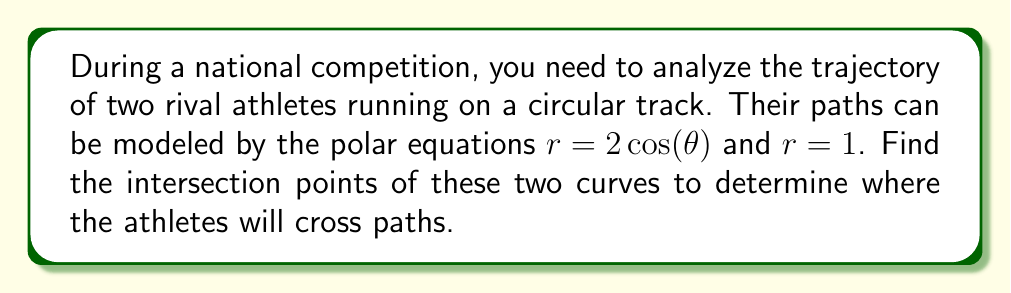Can you answer this question? To find the intersection points of the two polar curves, we need to solve the equation:

$2\cos(\theta) = 1$

Step 1: Isolate $\cos(\theta)$
$$\cos(\theta) = \frac{1}{2}$$

Step 2: Recall that $\cos(\theta) = \frac{1}{2}$ occurs at $\theta = \pm \frac{\pi}{3}$ in the interval $[0, 2\pi]$

Step 3: Convert the polar coordinates to Cartesian coordinates
For $\theta = \frac{\pi}{3}$:
$x = r\cos(\theta) = 1 \cdot \cos(\frac{\pi}{3}) = \frac{1}{2}$
$y = r\sin(\theta) = 1 \cdot \sin(\frac{\pi}{3}) = \frac{\sqrt{3}}{2}$

For $\theta = -\frac{\pi}{3}$ or $\frac{5\pi}{3}$:
$x = r\cos(\theta) = 1 \cdot \cos(-\frac{\pi}{3}) = \frac{1}{2}$
$y = r\sin(\theta) = 1 \cdot \sin(-\frac{\pi}{3}) = -\frac{\sqrt{3}}{2}$

Step 4: Verify these points satisfy both equations
For $r = 2\cos(\theta)$:
At $(\frac{1}{2}, \frac{\sqrt{3}}{2})$: $r = \sqrt{(\frac{1}{2})^2 + (\frac{\sqrt{3}}{2})^2} = 1 = 2\cos(\frac{\pi}{3})$
At $(\frac{1}{2}, -\frac{\sqrt{3}}{2})$: $r = \sqrt{(\frac{1}{2})^2 + (-\frac{\sqrt{3}}{2})^2} = 1 = 2\cos(-\frac{\pi}{3})$

For $r = 1$:
Both points lie on the unit circle, so they satisfy $r = 1$.

[asy]
import graph;
size(200);
real f(real t) {return 2*cos(t);}
real g(real t) {return 1;}

draw(polargraph(f,0,2*pi,operator ..),blue);
draw(polargraph(g,0,2*pi,operator ..),red);

dot((1/2,sqrt(3)/2),green);
dot((1/2,-sqrt(3)/2),green);

label("r = 2cos(θ)",(-1.5,0.5),blue);
label("r = 1",(0.5,0.5),red);
label("(1/2, √3/2)",(0.6,0.9),green);
label("(1/2, -√3/2)",(0.6,-0.9),green);
[/asy]
Answer: The intersection points are $(\frac{1}{2}, \frac{\sqrt{3}}{2})$ and $(\frac{1}{2}, -\frac{\sqrt{3}}{2})$ in Cartesian coordinates, or $(\frac{\pi}{3}, 1)$ and $(\frac{5\pi}{3}, 1)$ in polar coordinates. 